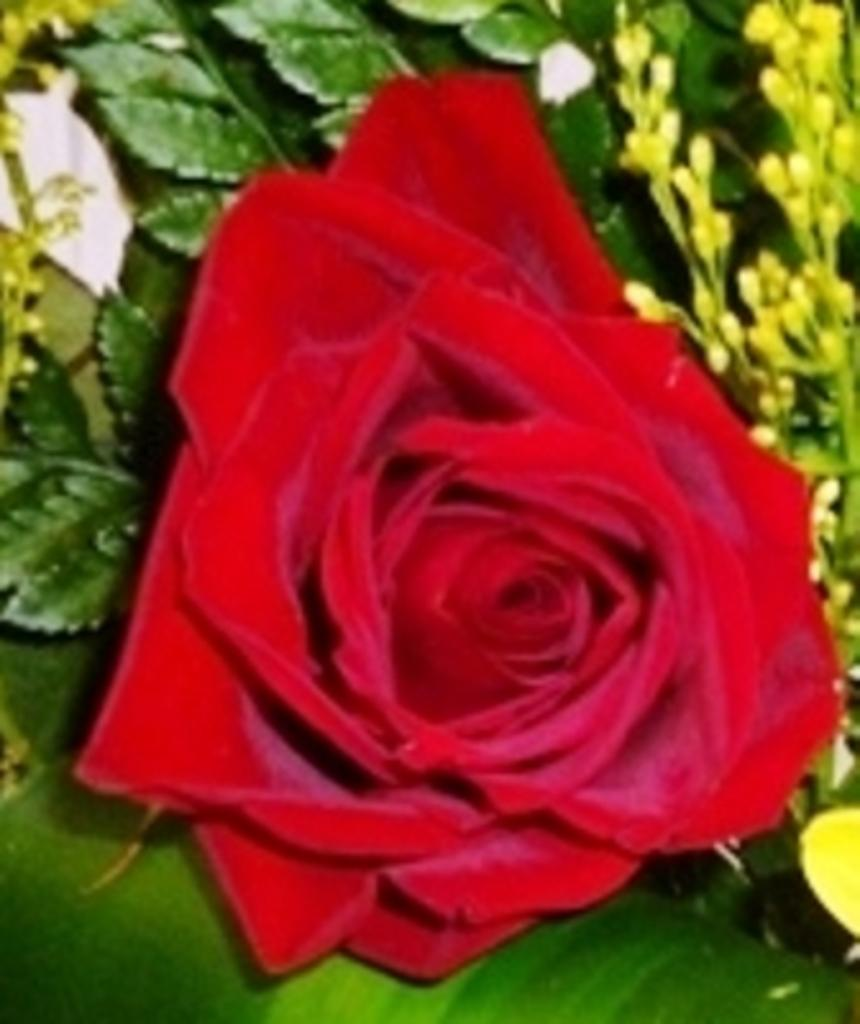What is the main subject of the image? There is a flower in the image. Can you describe the background of the image? There are leaves in the background of the image. How many children are present in the image? There are no children present in the image; it features a flower and leaves. What type of committee is depicted in the image? There is no committee depicted in the image; it features a flower and leaves. 